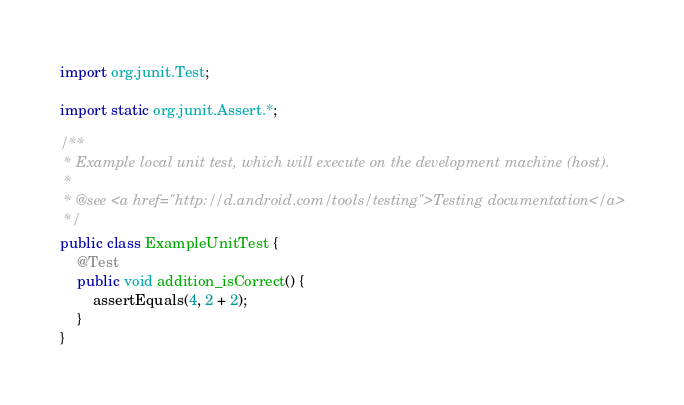<code> <loc_0><loc_0><loc_500><loc_500><_Java_>import org.junit.Test;

import static org.junit.Assert.*;

/**
 * Example local unit test, which will execute on the development machine (host).
 *
 * @see <a href="http://d.android.com/tools/testing">Testing documentation</a>
 */
public class ExampleUnitTest {
    @Test
    public void addition_isCorrect() {
        assertEquals(4, 2 + 2);
    }
}</code> 